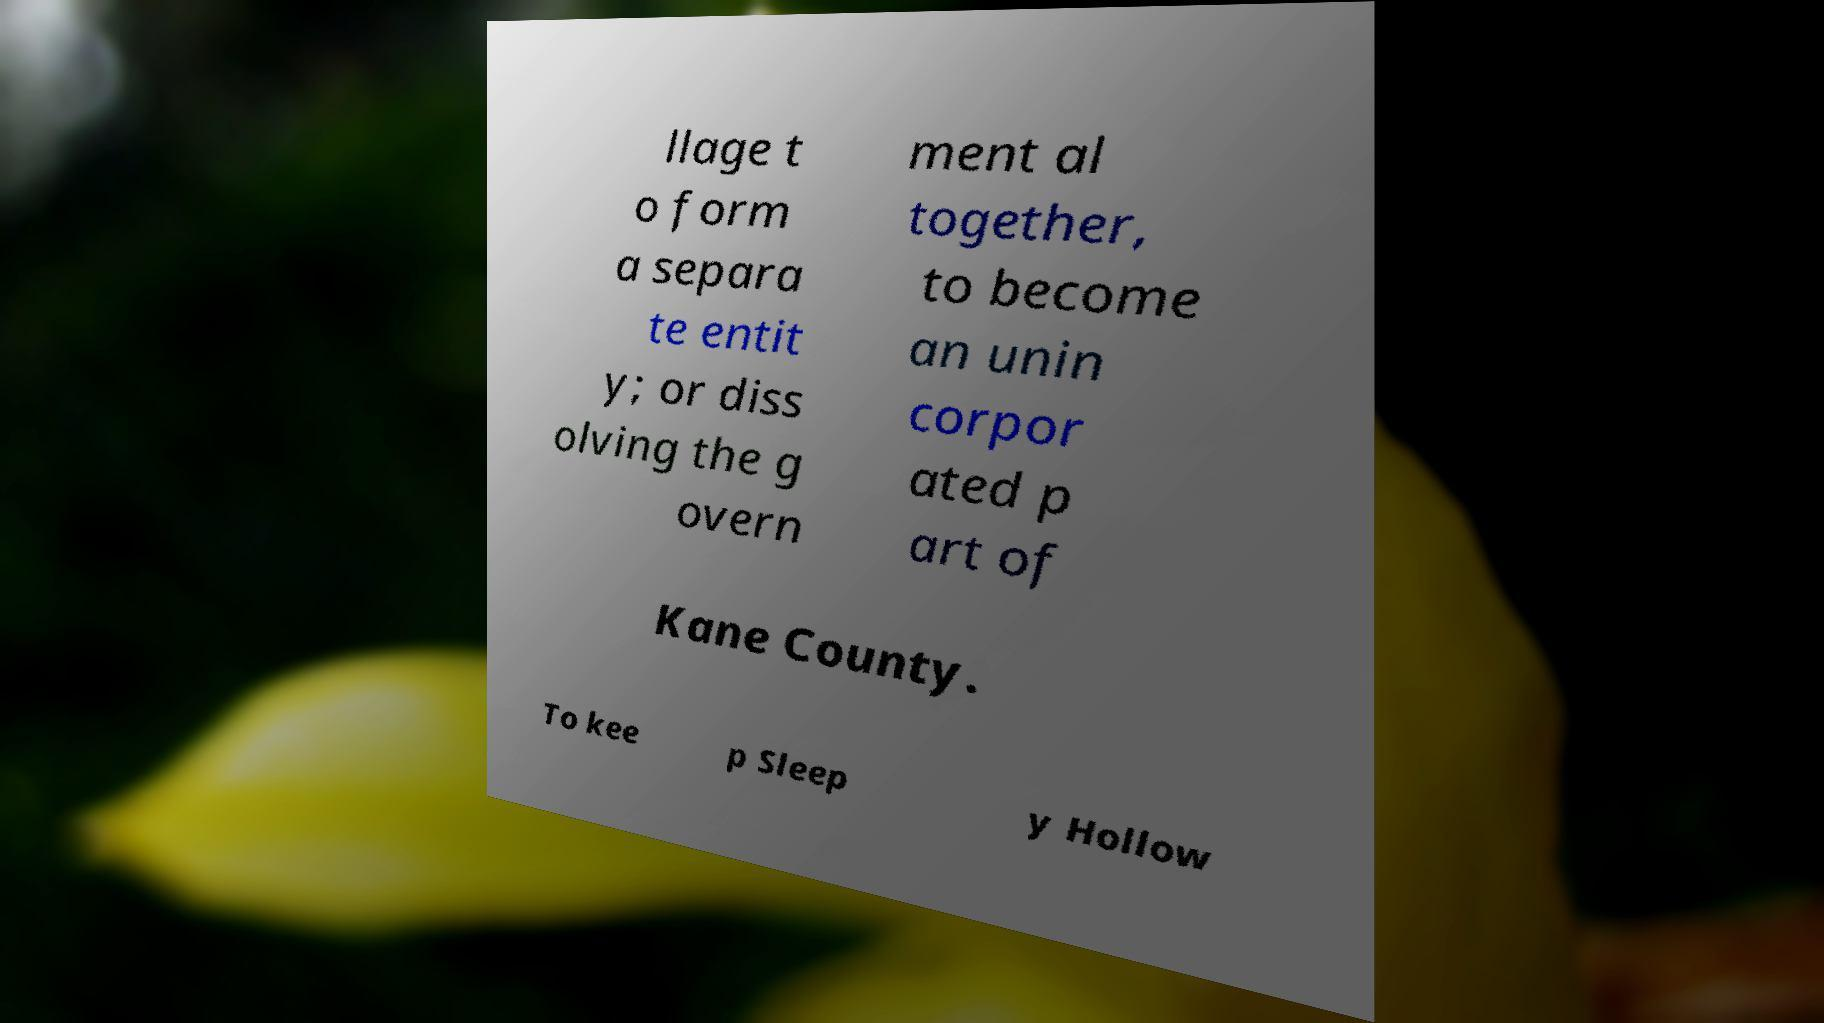Can you accurately transcribe the text from the provided image for me? llage t o form a separa te entit y; or diss olving the g overn ment al together, to become an unin corpor ated p art of Kane County. To kee p Sleep y Hollow 